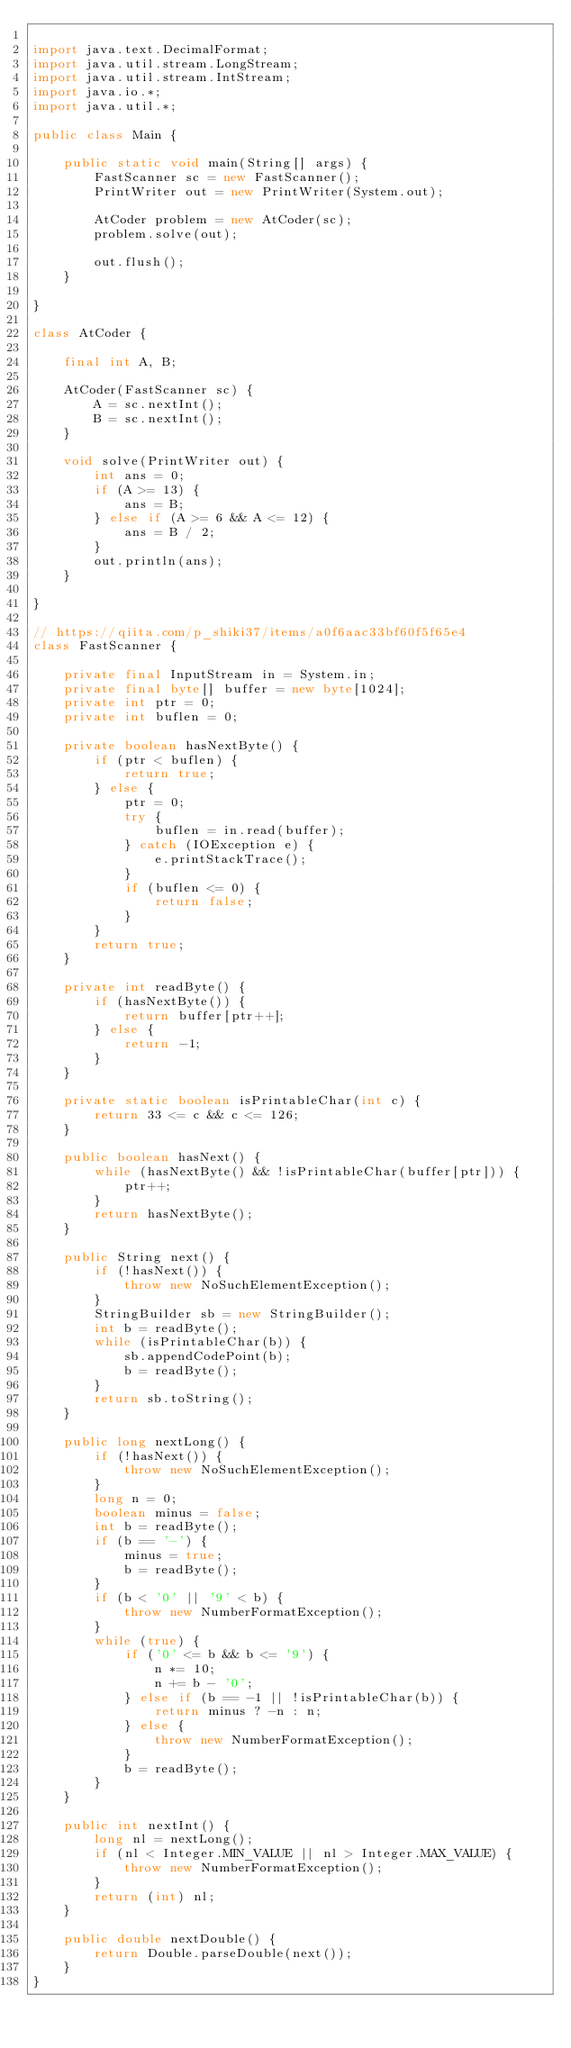<code> <loc_0><loc_0><loc_500><loc_500><_Java_>
import java.text.DecimalFormat;
import java.util.stream.LongStream;
import java.util.stream.IntStream;
import java.io.*;
import java.util.*;

public class Main {

    public static void main(String[] args) {
        FastScanner sc = new FastScanner();
        PrintWriter out = new PrintWriter(System.out);

        AtCoder problem = new AtCoder(sc);
        problem.solve(out);

        out.flush();
    }

}

class AtCoder {

    final int A, B;

    AtCoder(FastScanner sc) {
        A = sc.nextInt();
        B = sc.nextInt();
    }

    void solve(PrintWriter out) {
        int ans = 0;
        if (A >= 13) {
            ans = B;
        } else if (A >= 6 && A <= 12) {
            ans = B / 2;
        }
        out.println(ans);
    }

}

// https://qiita.com/p_shiki37/items/a0f6aac33bf60f5f65e4
class FastScanner {

    private final InputStream in = System.in;
    private final byte[] buffer = new byte[1024];
    private int ptr = 0;
    private int buflen = 0;

    private boolean hasNextByte() {
        if (ptr < buflen) {
            return true;
        } else {
            ptr = 0;
            try {
                buflen = in.read(buffer);
            } catch (IOException e) {
                e.printStackTrace();
            }
            if (buflen <= 0) {
                return false;
            }
        }
        return true;
    }

    private int readByte() {
        if (hasNextByte()) {
            return buffer[ptr++];
        } else {
            return -1;
        }
    }

    private static boolean isPrintableChar(int c) {
        return 33 <= c && c <= 126;
    }

    public boolean hasNext() {
        while (hasNextByte() && !isPrintableChar(buffer[ptr])) {
            ptr++;
        }
        return hasNextByte();
    }

    public String next() {
        if (!hasNext()) {
            throw new NoSuchElementException();
        }
        StringBuilder sb = new StringBuilder();
        int b = readByte();
        while (isPrintableChar(b)) {
            sb.appendCodePoint(b);
            b = readByte();
        }
        return sb.toString();
    }

    public long nextLong() {
        if (!hasNext()) {
            throw new NoSuchElementException();
        }
        long n = 0;
        boolean minus = false;
        int b = readByte();
        if (b == '-') {
            minus = true;
            b = readByte();
        }
        if (b < '0' || '9' < b) {
            throw new NumberFormatException();
        }
        while (true) {
            if ('0' <= b && b <= '9') {
                n *= 10;
                n += b - '0';
            } else if (b == -1 || !isPrintableChar(b)) {
                return minus ? -n : n;
            } else {
                throw new NumberFormatException();
            }
            b = readByte();
        }
    }

    public int nextInt() {
        long nl = nextLong();
        if (nl < Integer.MIN_VALUE || nl > Integer.MAX_VALUE) {
            throw new NumberFormatException();
        }
        return (int) nl;
    }

    public double nextDouble() {
        return Double.parseDouble(next());
    }
}
</code> 